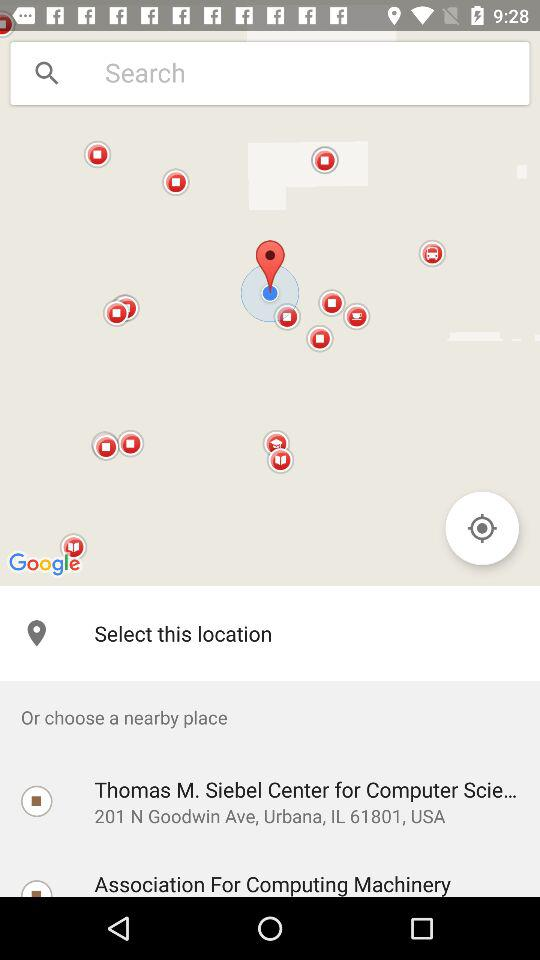What is the mentioned location? The mentioned location is 201 N Goodwin Ave, Urbana, IL 61801, USA. 